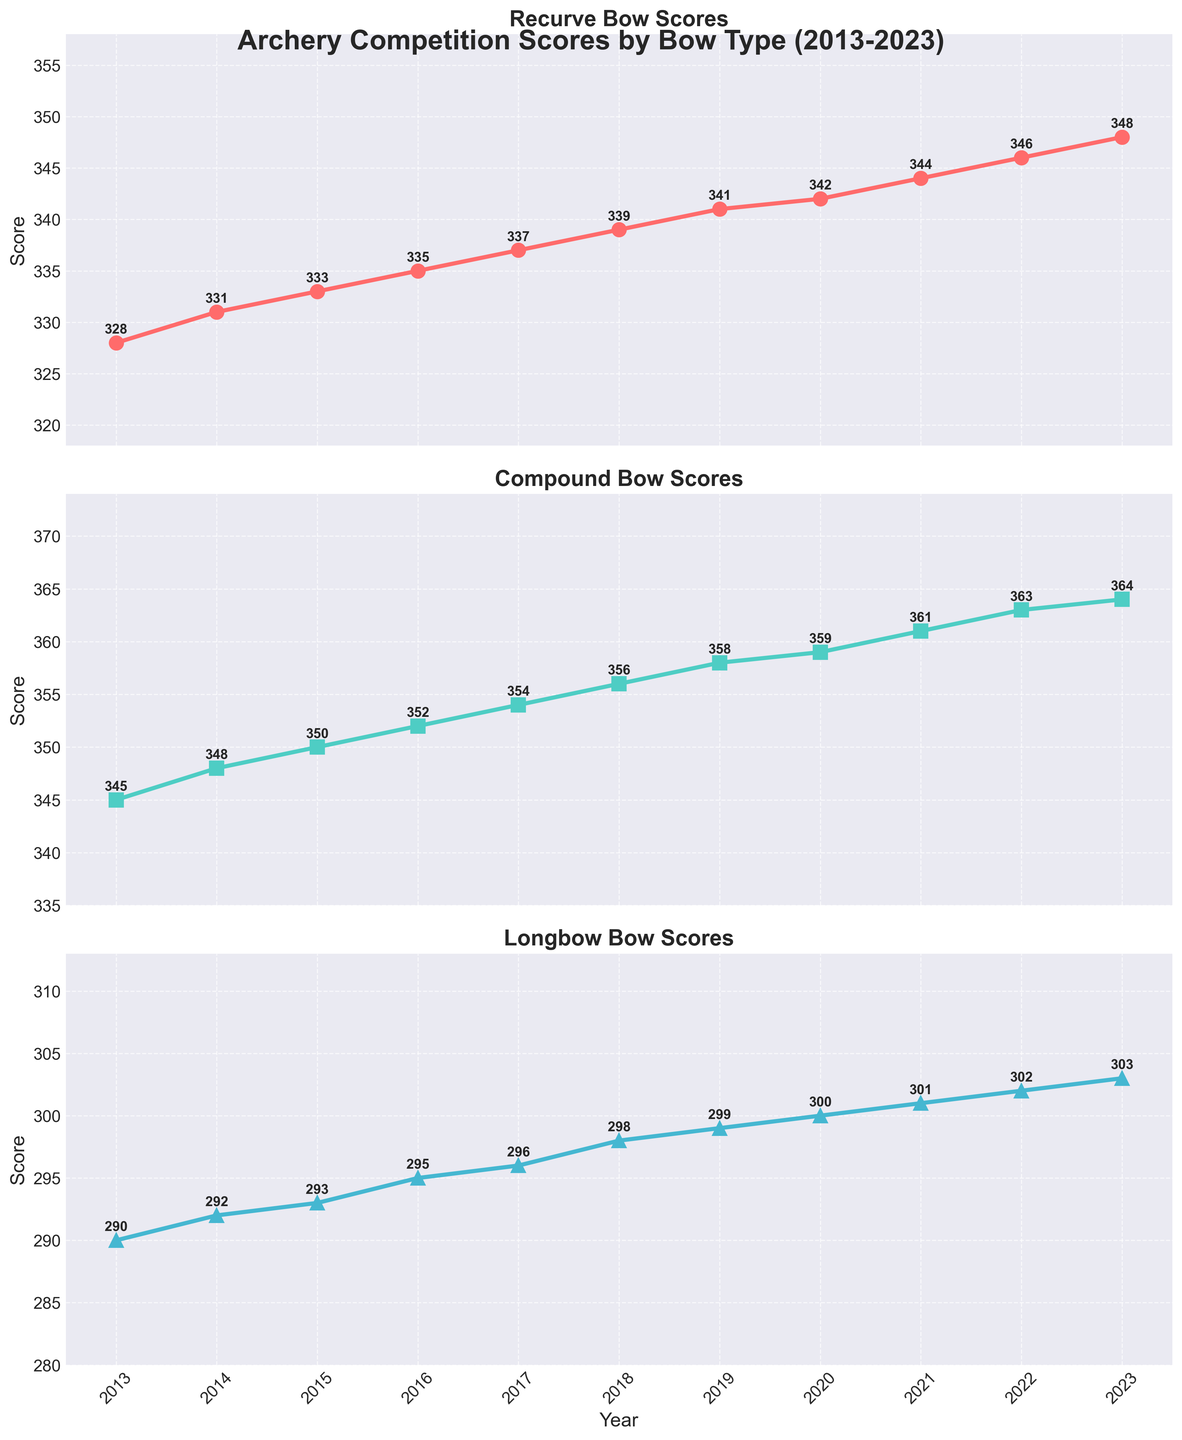What's the average score of the Compound bow over the past decade? We need to sum all scores from 2013 to 2023 for the Compound bow (345 + 348 + 350 + 352 + 354 + 356 + 358 + 359 + 361 + 363 + 364) and then divide by the number of years (11). The sum is 3910, and the average is 3910 / 11 = 355.45
Answer: 355.45 Which bow type showed the highest score in 2018? By looking at the 2018 scores on the respective subplots, we see that Recurve: 339, Compound: 356, Longbow: 298. The Compound bow had the highest score.
Answer: Compound How many points did the Longbow score increase from 2013 to 2023? Subtract the 2013 score from the 2023 score for the Longbow (303 - 290). The increase is 13 points.
Answer: 13 Which bow type had the most consistent improvement year over year? By visual inspection, all bow types seem to improve, but we can look at the incremental increases shown in the annotations. They all consistently increase year to year. Therefore, no bow type stands out as more consistent than another in annual improvement.
Answer: All bows In which year did all three bow types show an increase in scores compared to the previous year? Looking at year-over-year increments in the annotations, each year from 2013 to 2023 shows an increase in scores for all bow types.
Answer: 2014-2023 Compare the score difference between Recurve and Compound bows in 2019. From the annotations in 2019: Recurve scored 341 and Compound scored 358. The difference is 358 - 341 = 17.
Answer: 17 What visual markers differentiate each bow type's score line in the plot? The Recurve scores are marked with red circles, the Compound scores with green squares, and the Longbow scores with blue triangles.
Answer: Red circles, Green squares, Blue triangles Did any bow type score exactly 360 in any year? By examining the annotations for each subplot, only Compound reached 360 in 2021.
Answer: Yes, Compound in 2021 What's the combined score of all bow types in 2016? Sum the scores of Recurve (335), Compound (352), and Longbow (295) for 2016. The total is 335 + 352 + 295 = 982.
Answer: 982 